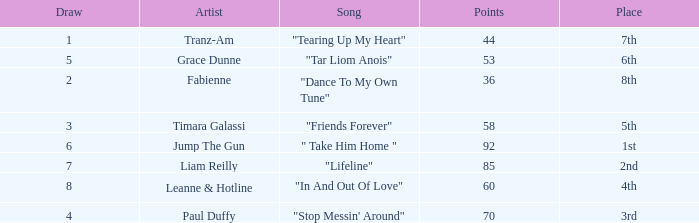What's the average draw for the song "stop messin' around"? 4.0. 